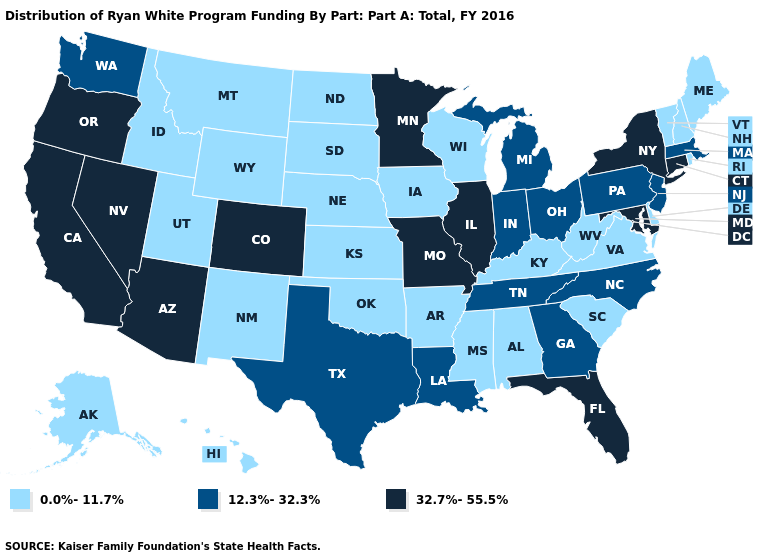What is the lowest value in the West?
Quick response, please. 0.0%-11.7%. What is the highest value in the USA?
Give a very brief answer. 32.7%-55.5%. Name the states that have a value in the range 32.7%-55.5%?
Keep it brief. Arizona, California, Colorado, Connecticut, Florida, Illinois, Maryland, Minnesota, Missouri, Nevada, New York, Oregon. Name the states that have a value in the range 0.0%-11.7%?
Give a very brief answer. Alabama, Alaska, Arkansas, Delaware, Hawaii, Idaho, Iowa, Kansas, Kentucky, Maine, Mississippi, Montana, Nebraska, New Hampshire, New Mexico, North Dakota, Oklahoma, Rhode Island, South Carolina, South Dakota, Utah, Vermont, Virginia, West Virginia, Wisconsin, Wyoming. What is the highest value in states that border Wyoming?
Be succinct. 32.7%-55.5%. Does Delaware have the highest value in the USA?
Write a very short answer. No. Name the states that have a value in the range 0.0%-11.7%?
Be succinct. Alabama, Alaska, Arkansas, Delaware, Hawaii, Idaho, Iowa, Kansas, Kentucky, Maine, Mississippi, Montana, Nebraska, New Hampshire, New Mexico, North Dakota, Oklahoma, Rhode Island, South Carolina, South Dakota, Utah, Vermont, Virginia, West Virginia, Wisconsin, Wyoming. What is the value of Alaska?
Write a very short answer. 0.0%-11.7%. Which states have the highest value in the USA?
Write a very short answer. Arizona, California, Colorado, Connecticut, Florida, Illinois, Maryland, Minnesota, Missouri, Nevada, New York, Oregon. What is the lowest value in the USA?
Be succinct. 0.0%-11.7%. Does Illinois have the highest value in the MidWest?
Be succinct. Yes. What is the highest value in states that border Montana?
Be succinct. 0.0%-11.7%. How many symbols are there in the legend?
Answer briefly. 3. Does New York have the highest value in the Northeast?
Be succinct. Yes. What is the value of Massachusetts?
Be succinct. 12.3%-32.3%. 